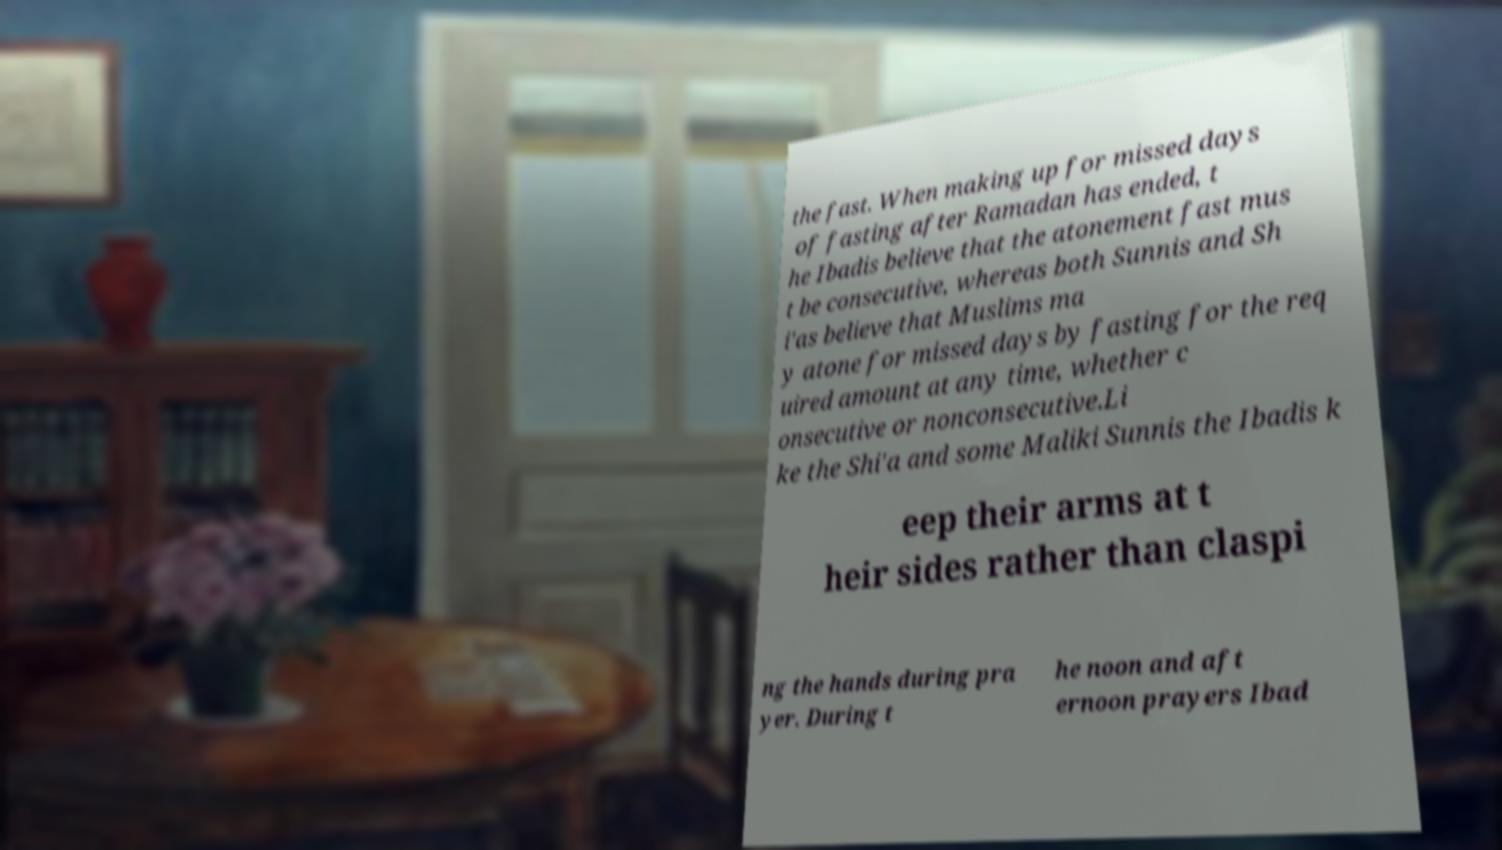Could you extract and type out the text from this image? the fast. When making up for missed days of fasting after Ramadan has ended, t he Ibadis believe that the atonement fast mus t be consecutive, whereas both Sunnis and Sh i'as believe that Muslims ma y atone for missed days by fasting for the req uired amount at any time, whether c onsecutive or nonconsecutive.Li ke the Shi'a and some Maliki Sunnis the Ibadis k eep their arms at t heir sides rather than claspi ng the hands during pra yer. During t he noon and aft ernoon prayers Ibad 